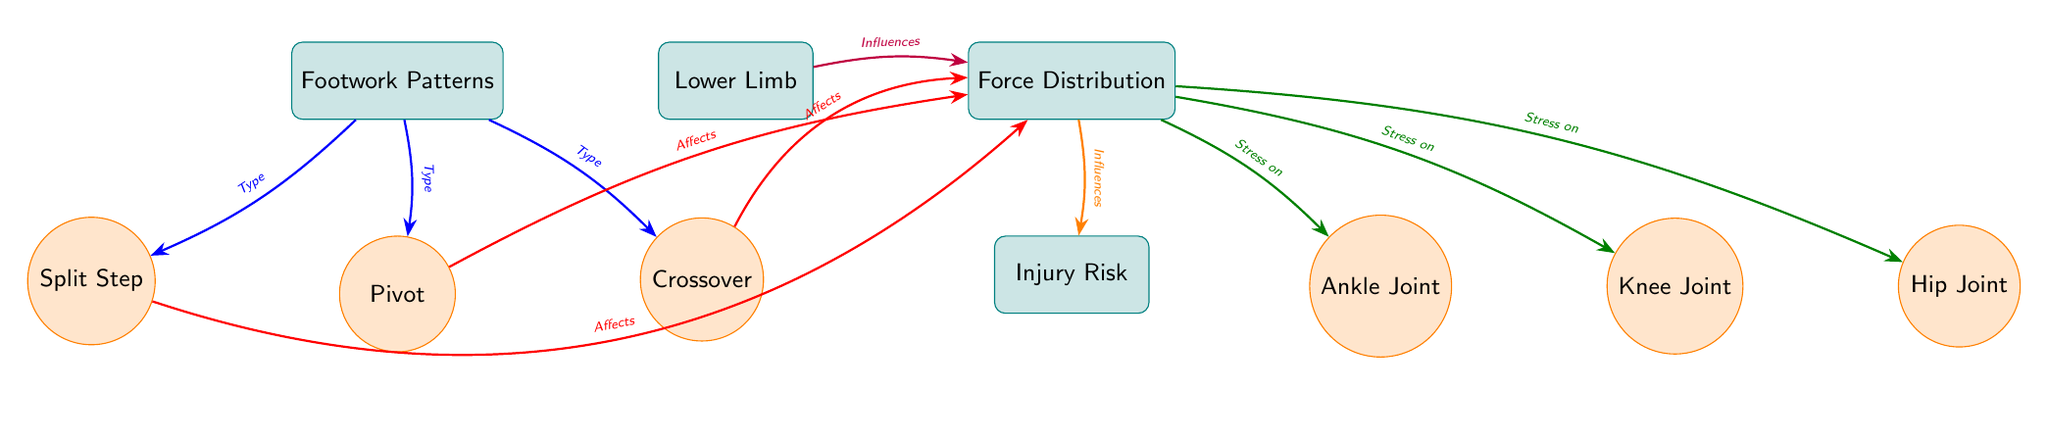What is the main focus of the diagram? The diagram primarily focuses on the relationship between footwork patterns and their impact on force distribution in the lower limb, ultimately affecting injury risk. This is evident from the central nodes and the arrows pointing to and from "Footwork Patterns" and "Force Distribution."
Answer: Force Distribution on the Lower Limb How many footwork patterns are shown in the diagram? There are three footwork patterns depicted in the diagram: Split Step, Pivot, and Crossover. Each pattern has its own circular node that connects to the main "Footwork Patterns" box.
Answer: Three What does "Force Distribution" influence in the diagram? The "Force Distribution" directly influences the "Injury Risk," as indicated by the arrow flowing from "Force Distribution" to the "Injury Risk" box.
Answer: Injury Risk Which joint is directly affected by the "Crossover" footwork pattern? The "Crossover" footwork pattern affects the "Force Distribution," which in turn affects the stresses placed on different joints, including the ankle, knee, and hip. However, the direct connection from "Crossover" to "Force Distribution" indicates its influence on all joints.
Answer: All joints (Ankle, Knee, Hip) What color represents the arrows that indicate the influence of "Footwork Patterns" on "Force Distribution"? The arrows indicating the influence of "Footwork Patterns" on "Force Distribution" are colored blue. This is noted by identifying the arrows that connect "Footwork Patterns" to the specific footwork nodes.
Answer: Blue What type of relationship exists between "Force Distribution" and the lower limb? The relationship is that the lower limb influences the "Force Distribution," as shown by the arrow pointing from the "Lower Limb" box to "Force Distribution" with the label "Influences." This signifies a direction of impact from one node to another.
Answer: Influences 